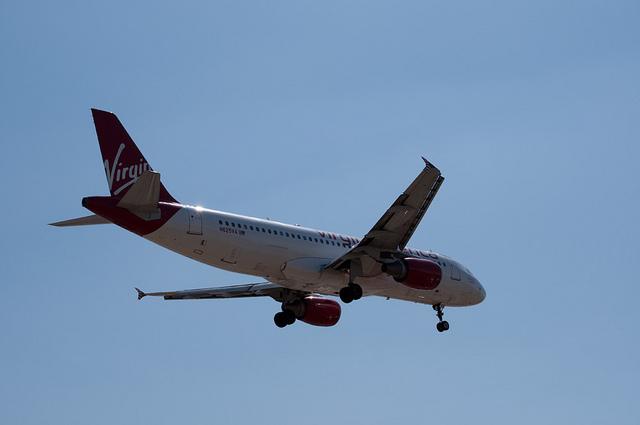What airline name is seen on the tail?
Concise answer only. Virgin. Are the planes front wheels in or out?
Answer briefly. Out. What color is the plane?
Be succinct. White and red. Where is the landing gear?
Give a very brief answer. Under plane. 